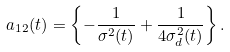Convert formula to latex. <formula><loc_0><loc_0><loc_500><loc_500>a _ { 1 2 } ( t ) = \left \{ - \frac { 1 } { \sigma ^ { 2 } ( t ) } + \frac { 1 } { 4 \sigma ^ { 2 } _ { d } ( t ) } \right \} .</formula> 